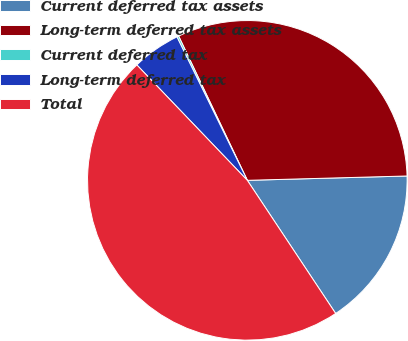Convert chart. <chart><loc_0><loc_0><loc_500><loc_500><pie_chart><fcel>Current deferred tax assets<fcel>Long-term deferred tax assets<fcel>Current deferred tax<fcel>Long-term deferred tax<fcel>Total<nl><fcel>16.11%<fcel>31.64%<fcel>0.19%<fcel>4.89%<fcel>47.17%<nl></chart> 